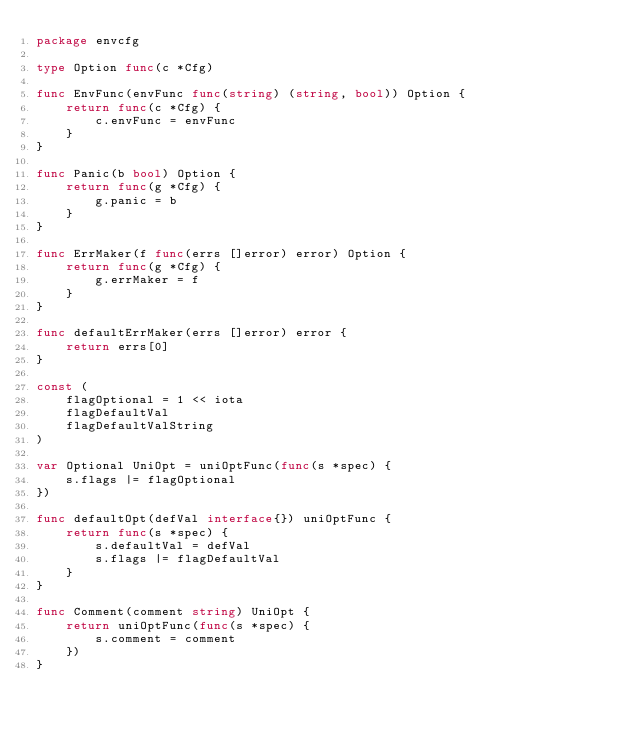<code> <loc_0><loc_0><loc_500><loc_500><_Go_>package envcfg

type Option func(c *Cfg)

func EnvFunc(envFunc func(string) (string, bool)) Option {
	return func(c *Cfg) {
		c.envFunc = envFunc
	}
}

func Panic(b bool) Option {
	return func(g *Cfg) {
		g.panic = b
	}
}

func ErrMaker(f func(errs []error) error) Option {
	return func(g *Cfg) {
		g.errMaker = f
	}
}

func defaultErrMaker(errs []error) error {
	return errs[0]
}

const (
	flagOptional = 1 << iota
	flagDefaultVal
	flagDefaultValString
)

var Optional UniOpt = uniOptFunc(func(s *spec) {
	s.flags |= flagOptional
})

func defaultOpt(defVal interface{}) uniOptFunc {
	return func(s *spec) {
		s.defaultVal = defVal
		s.flags |= flagDefaultVal
	}
}

func Comment(comment string) UniOpt {
	return uniOptFunc(func(s *spec) {
		s.comment = comment
	})
}
</code> 